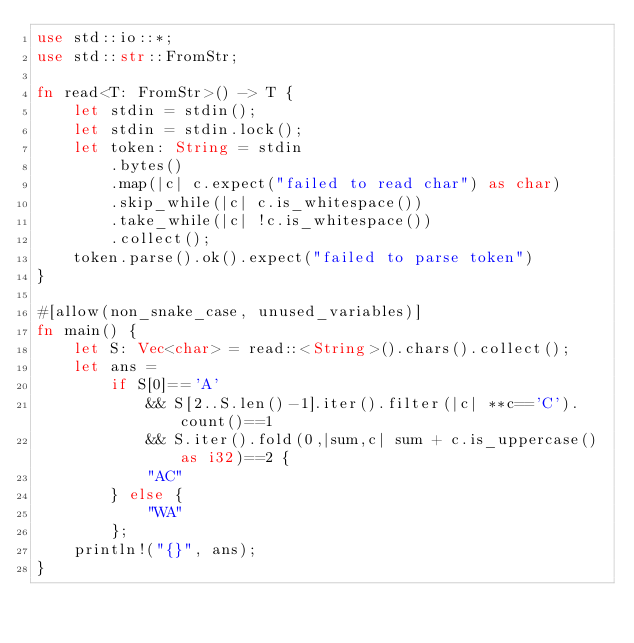<code> <loc_0><loc_0><loc_500><loc_500><_Rust_>use std::io::*;
use std::str::FromStr;
 
fn read<T: FromStr>() -> T {
    let stdin = stdin();
    let stdin = stdin.lock();
    let token: String = stdin
        .bytes()
        .map(|c| c.expect("failed to read char") as char) 
        .skip_while(|c| c.is_whitespace())
        .take_while(|c| !c.is_whitespace())
        .collect();
    token.parse().ok().expect("failed to parse token")
}
 
#[allow(non_snake_case, unused_variables)]
fn main() {
    let S: Vec<char> = read::<String>().chars().collect();
    let ans = 
        if S[0]=='A'
            && S[2..S.len()-1].iter().filter(|c| **c=='C').count()==1 
            && S.iter().fold(0,|sum,c| sum + c.is_uppercase() as i32)==2 {
            "AC"
        } else {
            "WA"
        };
    println!("{}", ans);
}

</code> 